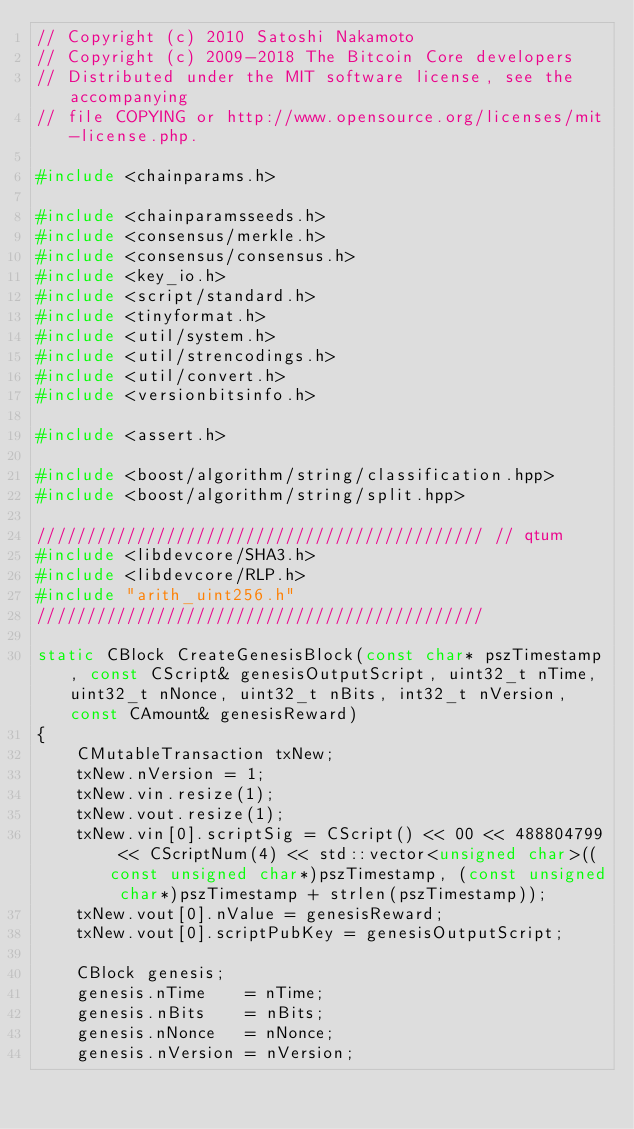Convert code to text. <code><loc_0><loc_0><loc_500><loc_500><_C++_>// Copyright (c) 2010 Satoshi Nakamoto
// Copyright (c) 2009-2018 The Bitcoin Core developers
// Distributed under the MIT software license, see the accompanying
// file COPYING or http://www.opensource.org/licenses/mit-license.php.

#include <chainparams.h>

#include <chainparamsseeds.h>
#include <consensus/merkle.h>
#include <consensus/consensus.h>
#include <key_io.h>
#include <script/standard.h>
#include <tinyformat.h>
#include <util/system.h>
#include <util/strencodings.h>
#include <util/convert.h>
#include <versionbitsinfo.h>

#include <assert.h>

#include <boost/algorithm/string/classification.hpp>
#include <boost/algorithm/string/split.hpp>

///////////////////////////////////////////// // qtum
#include <libdevcore/SHA3.h>
#include <libdevcore/RLP.h>
#include "arith_uint256.h"
/////////////////////////////////////////////

static CBlock CreateGenesisBlock(const char* pszTimestamp, const CScript& genesisOutputScript, uint32_t nTime, uint32_t nNonce, uint32_t nBits, int32_t nVersion, const CAmount& genesisReward)
{
    CMutableTransaction txNew;
    txNew.nVersion = 1;
    txNew.vin.resize(1);
    txNew.vout.resize(1);
    txNew.vin[0].scriptSig = CScript() << 00 << 488804799 << CScriptNum(4) << std::vector<unsigned char>((const unsigned char*)pszTimestamp, (const unsigned char*)pszTimestamp + strlen(pszTimestamp));
    txNew.vout[0].nValue = genesisReward;
    txNew.vout[0].scriptPubKey = genesisOutputScript;

    CBlock genesis;
    genesis.nTime    = nTime;
    genesis.nBits    = nBits;
    genesis.nNonce   = nNonce;
    genesis.nVersion = nVersion;</code> 